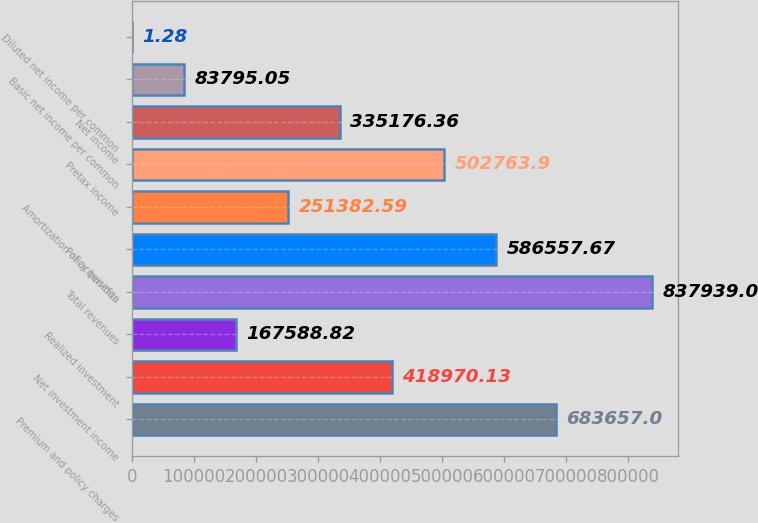Convert chart to OTSL. <chart><loc_0><loc_0><loc_500><loc_500><bar_chart><fcel>Premium and policy charges<fcel>Net investment income<fcel>Realized investment<fcel>Total revenues<fcel>Policy benefits<fcel>Amortization of acquisition<fcel>Pretax income<fcel>Net income<fcel>Basic net income per common<fcel>Diluted net income per common<nl><fcel>683657<fcel>418970<fcel>167589<fcel>837939<fcel>586558<fcel>251383<fcel>502764<fcel>335176<fcel>83795.1<fcel>1.28<nl></chart> 